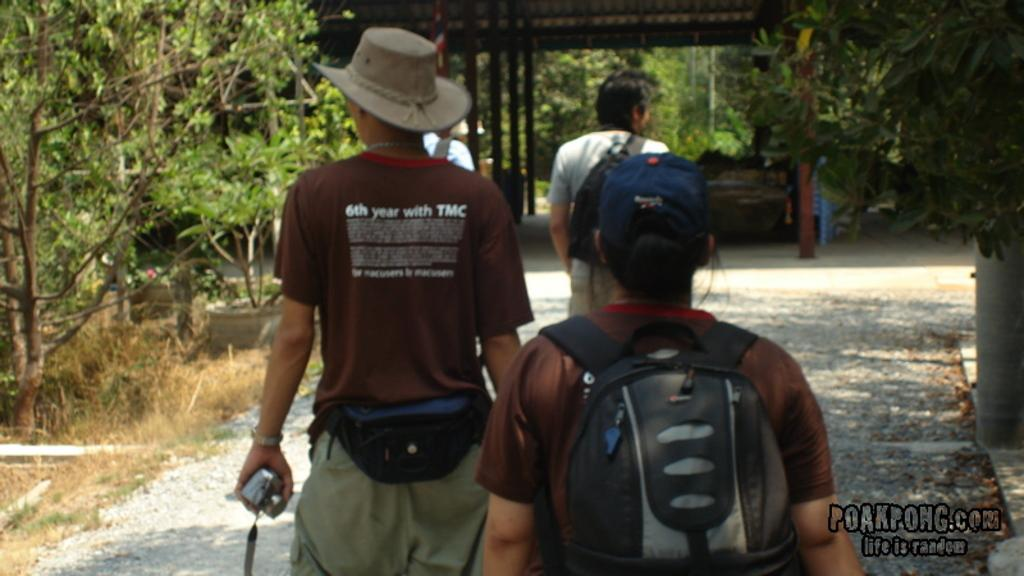Provide a one-sentence caption for the provided image. people walking in a park and one wears a shirt that says "6th year with TMC". 